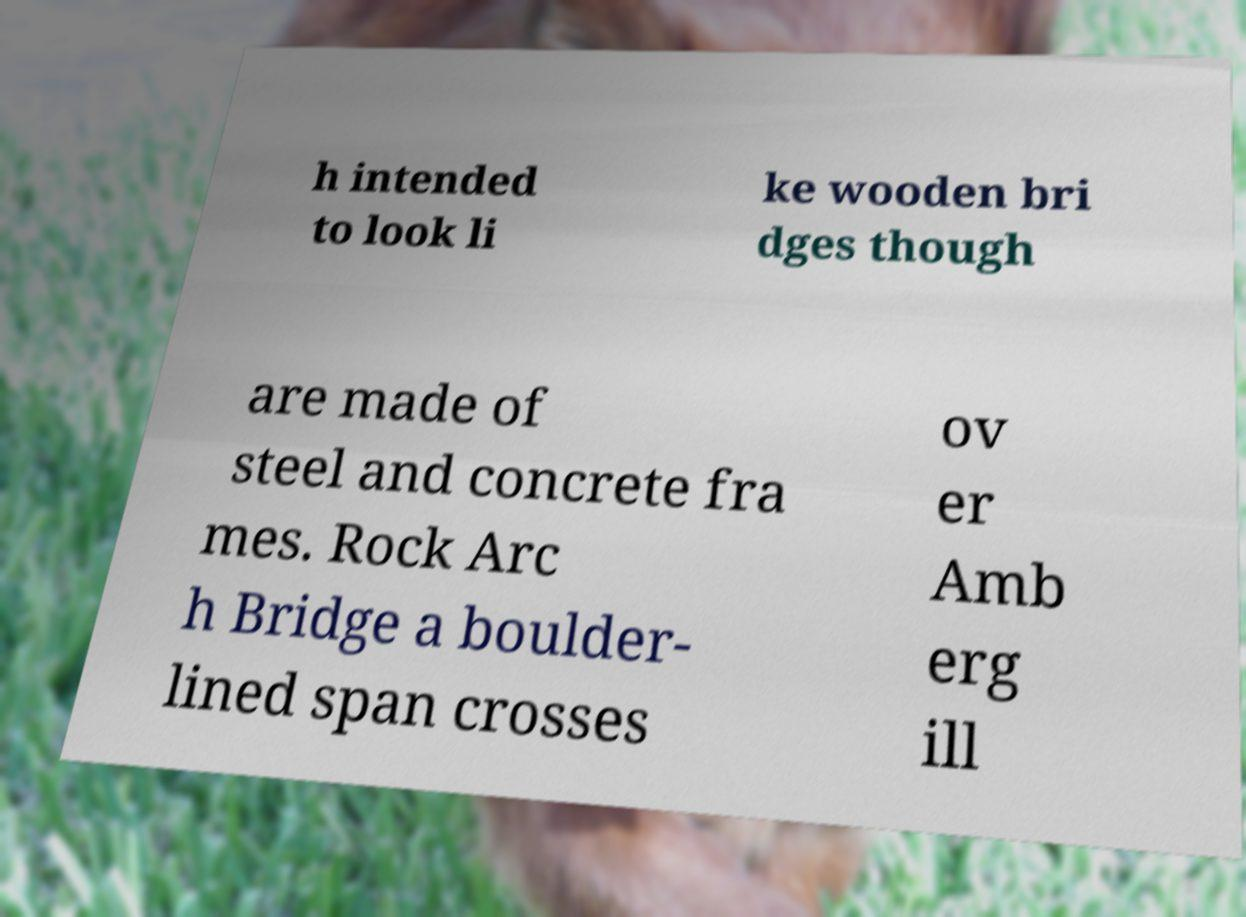There's text embedded in this image that I need extracted. Can you transcribe it verbatim? h intended to look li ke wooden bri dges though are made of steel and concrete fra mes. Rock Arc h Bridge a boulder- lined span crosses ov er Amb erg ill 